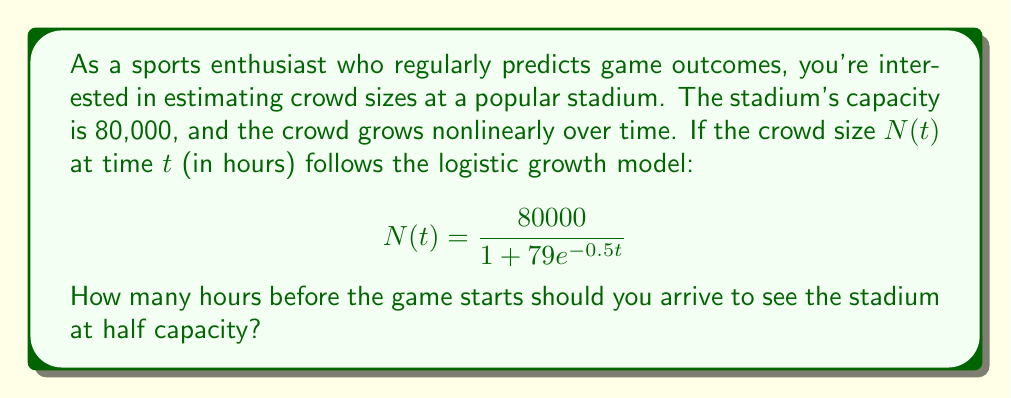Help me with this question. Let's approach this step-by-step:

1) We want to find $t$ when $N(t) = 40000$ (half of 80000).

2) Substitute this into our equation:

   $$40000 = \frac{80000}{1 + 79e^{-0.5t}}$$

3) Multiply both sides by $(1 + 79e^{-0.5t})$:

   $$40000(1 + 79e^{-0.5t}) = 80000$$

4) Distribute on the left side:

   $$40000 + 3160000e^{-0.5t} = 80000$$

5) Subtract 40000 from both sides:

   $$3160000e^{-0.5t} = 40000$$

6) Divide both sides by 3160000:

   $$e^{-0.5t} = \frac{1}{79}$$

7) Take the natural log of both sides:

   $$-0.5t = \ln(\frac{1}{79})$$

8) Divide both sides by -0.5:

   $$t = -\frac{2}{1}\ln(\frac{1}{79}) = 2\ln(79)$$

9) Calculate the final value:

   $$t \approx 8.73 \text{ hours}$$

Therefore, you should arrive approximately 8.73 hours before the game starts to see the stadium at half capacity.
Answer: 8.73 hours 